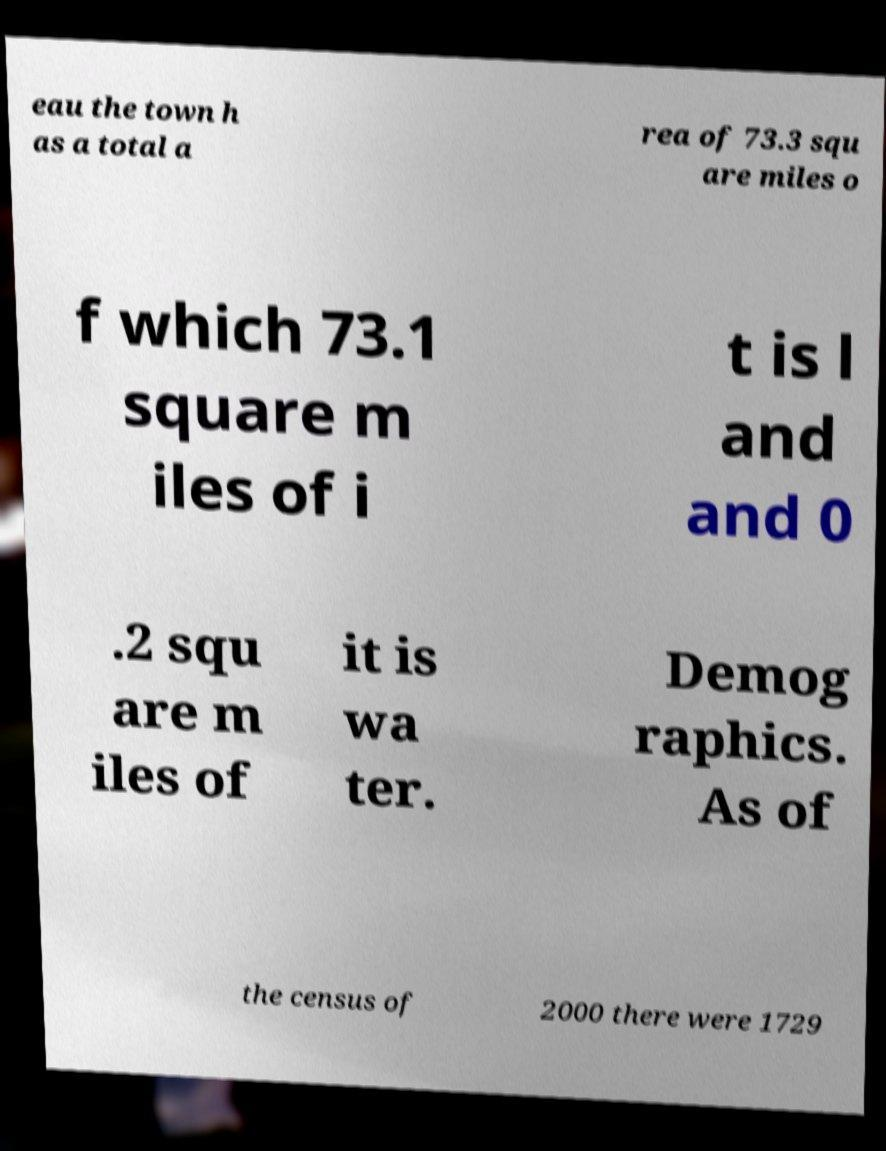I need the written content from this picture converted into text. Can you do that? eau the town h as a total a rea of 73.3 squ are miles o f which 73.1 square m iles of i t is l and and 0 .2 squ are m iles of it is wa ter. Demog raphics. As of the census of 2000 there were 1729 